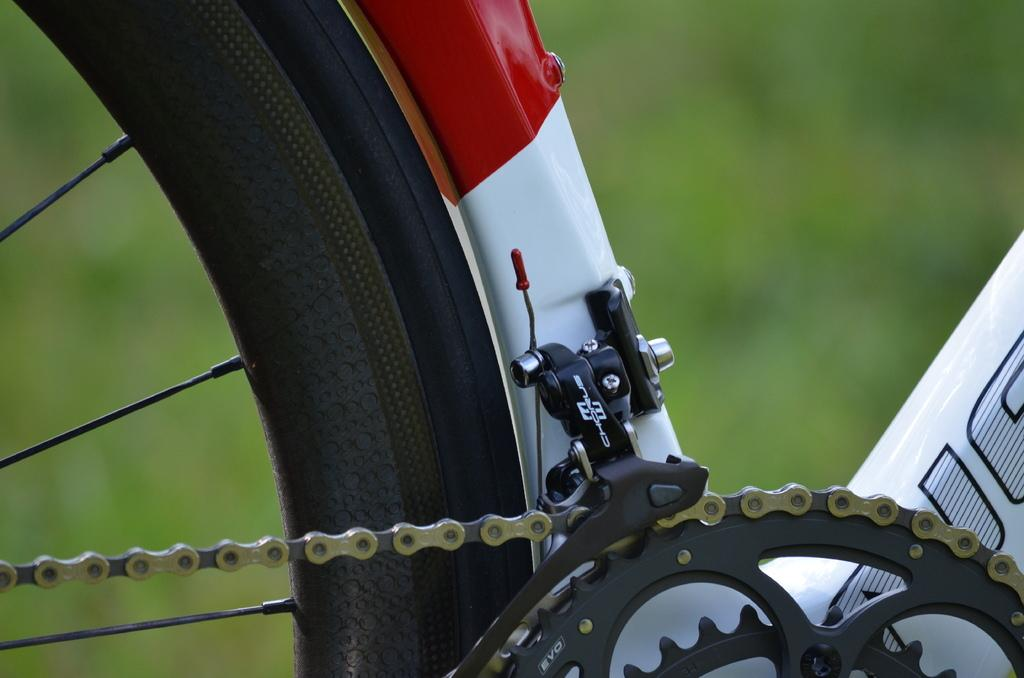What type of object is partially visible in the image? There is a part of a bicycle in the image. What specific part of the bicycle can be seen? There is a wheel with a chain in the image. Can you describe the background of the image? The background of the image is blurred. What type of jeans is the shop selling in the image? There is no shop or jeans present in the image; it features a part of a bicycle with a wheel and chain. What time of day is depicted in the image? The time of day cannot be determined from the image, as there are no specific time-related details provided. 